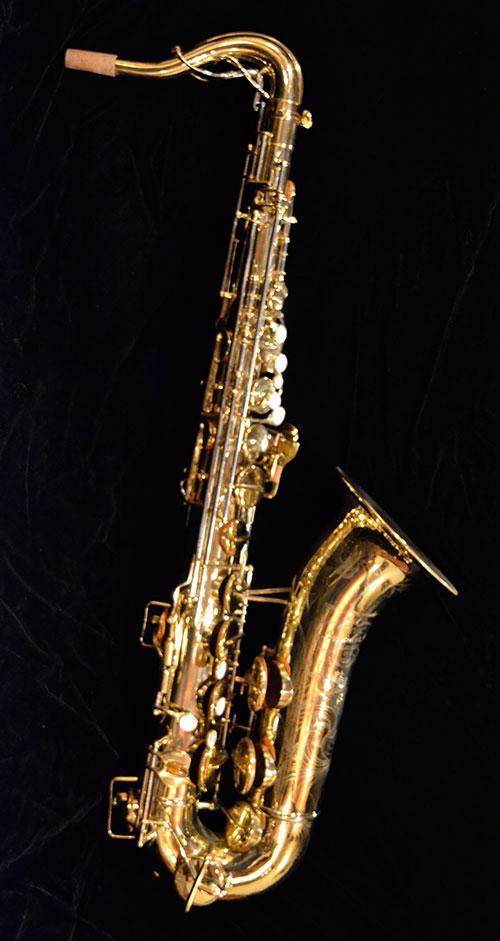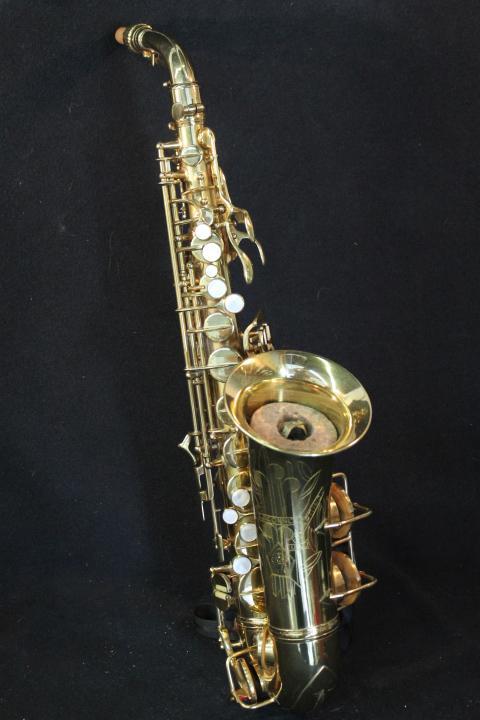The first image is the image on the left, the second image is the image on the right. Evaluate the accuracy of this statement regarding the images: "Each image shows a single saxophone displayed so it is nearly vertical.". Is it true? Answer yes or no. Yes. The first image is the image on the left, the second image is the image on the right. For the images displayed, is the sentence "Both saxophones are positioned upright." factually correct? Answer yes or no. Yes. 